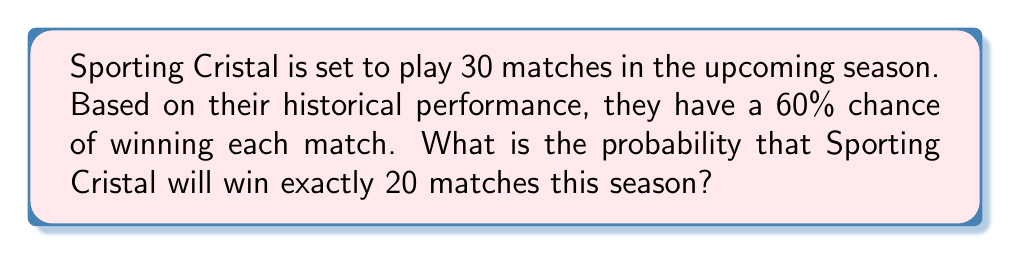Can you answer this question? To solve this problem, we'll use the binomial distribution formula, as we're calculating the probability of a specific number of successes (wins) in a fixed number of independent trials (matches).

1. Identify the parameters:
   $n = 30$ (total number of matches)
   $k = 20$ (number of wins we're interested in)
   $p = 0.60$ (probability of winning a single match)
   $q = 1 - p = 0.40$ (probability of not winning a single match)

2. The binomial distribution formula is:

   $$P(X = k) = \binom{n}{k} p^k q^{n-k}$$

3. Calculate the binomial coefficient:
   $$\binom{30}{20} = \frac{30!}{20!(30-20)!} = \frac{30!}{20!10!} = 30,045,015$$

4. Substitute values into the formula:
   $$P(X = 20) = 30,045,015 \cdot (0.60)^{20} \cdot (0.40)^{10}$$

5. Calculate the result:
   $$P(X = 20) = 30,045,015 \cdot 0.0003656158 \cdot 0.0000104858 \approx 0.1151$$

Therefore, the probability of Sporting Cristal winning exactly 20 matches out of 30 is approximately 0.1151 or 11.51%.
Answer: 0.1151 